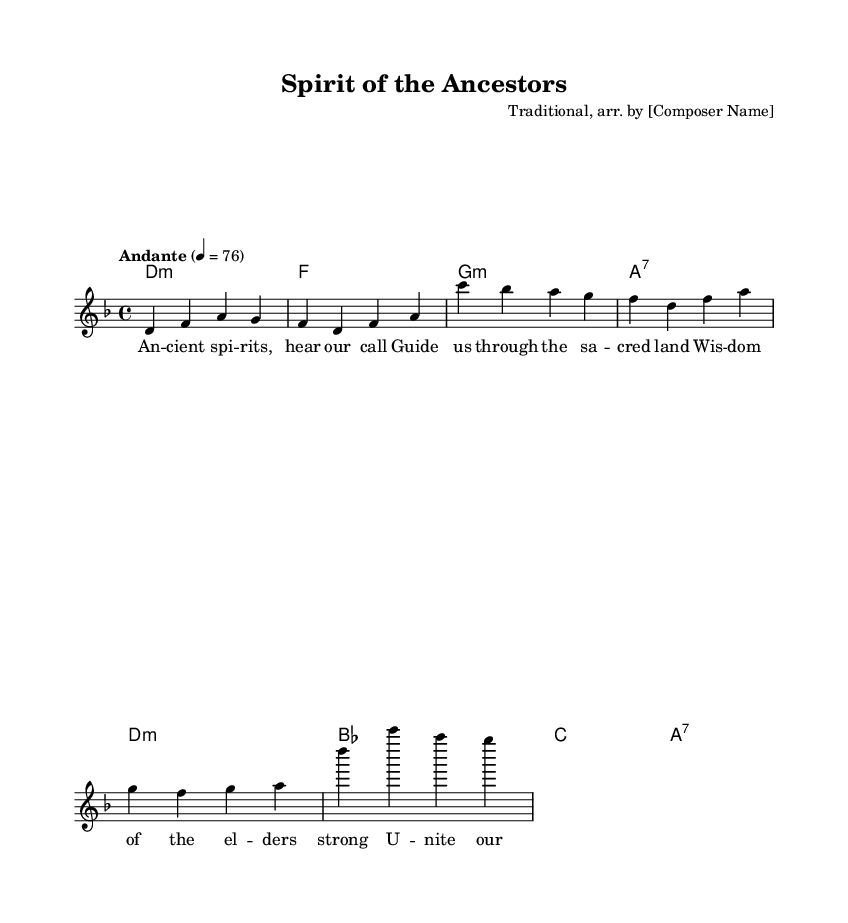What is the key signature of this music? The key signature is indicated at the beginning of the staff, showing two flats, which corresponds to the key of D minor.
Answer: D minor What is the time signature of this music? The time signature is shown as a fraction at the beginning, indicating four beats per measure with each quarter note getting one beat. This is represented as 4/4.
Answer: 4/4 What is the tempo marking given in the sheet music? The tempo is indicated above the staff, stating "Andante" and suggests a moderate speed, specifically set to a metronome marking of 76 beats per minute.
Answer: Andante, 76 How many measures does the melody contain? By counting the sequences of notes and separating them by the vertical bar lines (bar lines), there are a total of four measures in the melody section.
Answer: Four What is the emotional theme of the lyrics based on their content? The lyrics refer to ancient spirits, guidance, unity among tribal members, and wisdom from elders, reflecting themes of heritage and cultural connection to land.
Answer: Cultural connection Which musical form does this song represent, based on its structure? The song follows a simple verse structure where the melody is accompanied by chord progressions that support the lyrics, typical for folk ballads.
Answer: Verse structure What type of accompaniment is provided in this piece? The accompaniment is a set of chords indicated below the melody line, which outlines the harmonic framework typical for folk music to support the vocal melody.
Answer: Chord accompaniment 